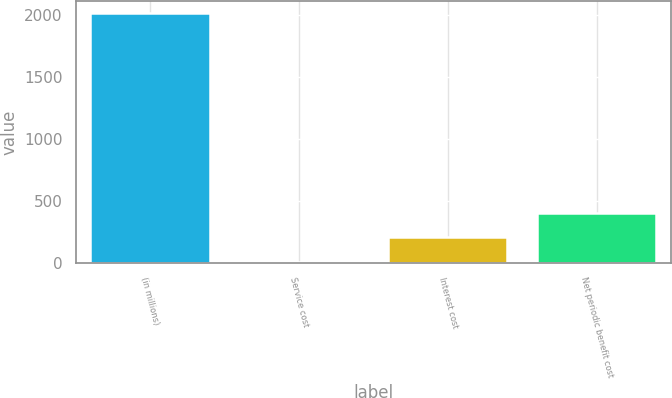Convert chart. <chart><loc_0><loc_0><loc_500><loc_500><bar_chart><fcel>(in millions)<fcel>Service cost<fcel>Interest cost<fcel>Net periodic benefit cost<nl><fcel>2012<fcel>3<fcel>203.9<fcel>404.8<nl></chart> 